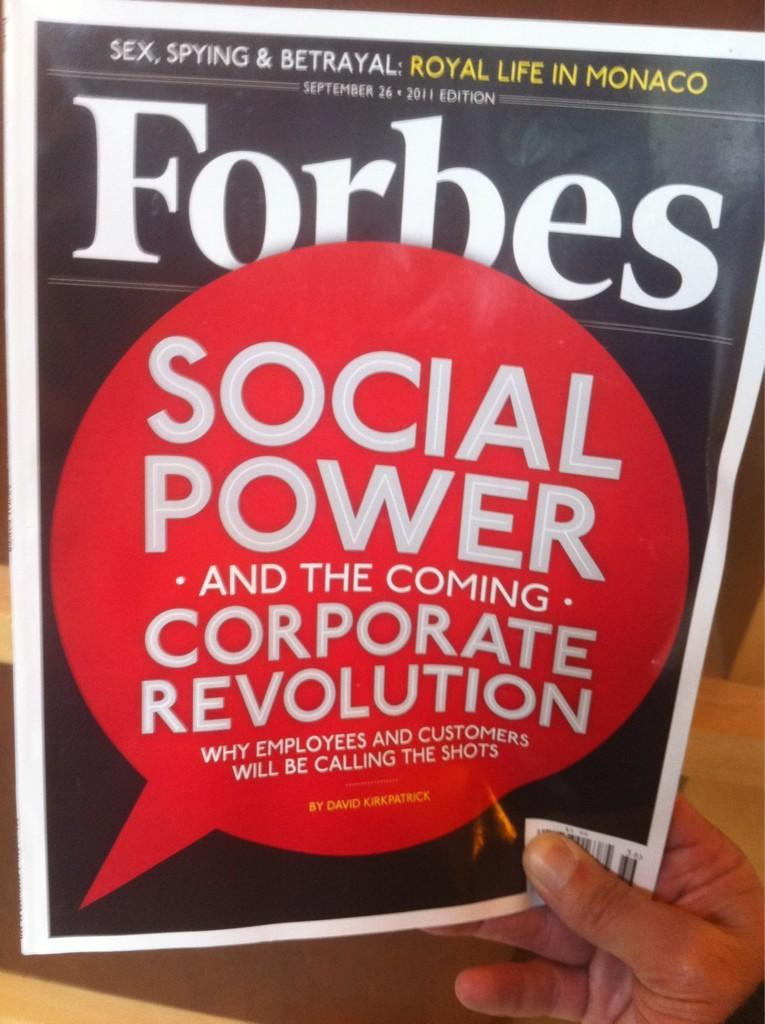Provide a one-sentence caption for the provided image. A cover of Forbes magazine shows that there is a story about social power in this issue. 